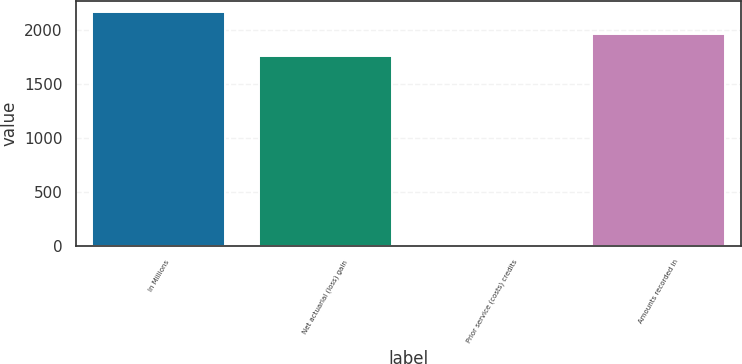Convert chart. <chart><loc_0><loc_0><loc_500><loc_500><bar_chart><fcel>In Millions<fcel>Net actuarial (loss) gain<fcel>Prior service (costs) credits<fcel>Amounts recorded in<nl><fcel>2166.28<fcel>1764.1<fcel>7.1<fcel>1965.19<nl></chart> 